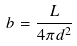Convert formula to latex. <formula><loc_0><loc_0><loc_500><loc_500>b = \frac { L } { 4 \pi d ^ { 2 } }</formula> 